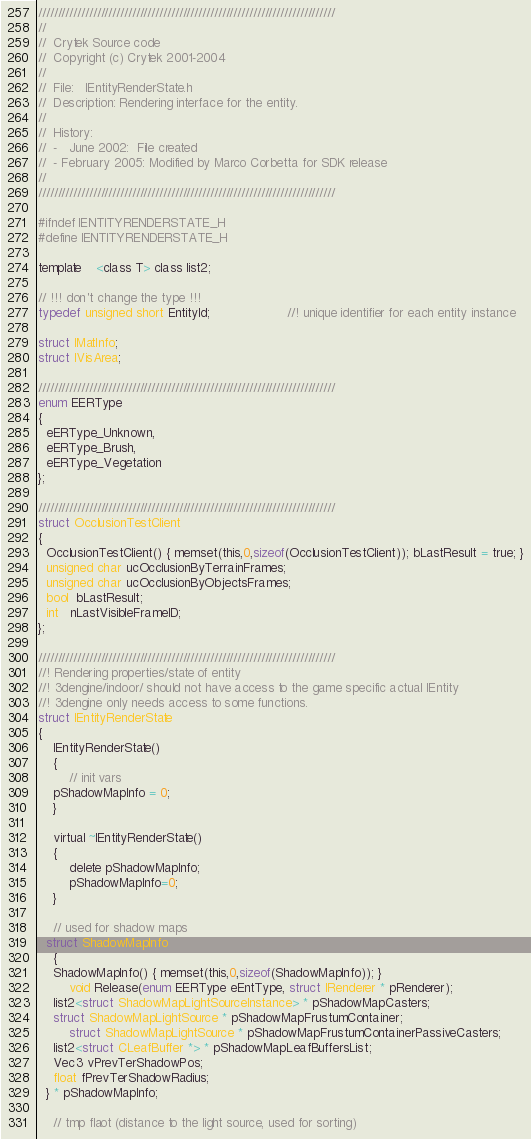Convert code to text. <code><loc_0><loc_0><loc_500><loc_500><_C_>
////////////////////////////////////////////////////////////////////////////
//
//	Crytek Source code 
//	Copyright (c) Crytek 2001-2004
//
//  File:   IEntityRenderState.h
//  Description: Rendering interface for the entity.
//
//  History:
//	-	June 2002:	File created
//	- February 2005: Modified by Marco Corbetta for SDK release
//
////////////////////////////////////////////////////////////////////////////

#ifndef IENTITYRENDERSTATE_H
#define IENTITYRENDERSTATE_H

template	<class T> class list2;

// !!! don't change the type !!!
typedef unsigned short EntityId;					//! unique identifier for each entity instance

struct IMatInfo;
struct IVisArea;

////////////////////////////////////////////////////////////////////////////
enum EERType
{
  eERType_Unknown,
  eERType_Brush,
  eERType_Vegetation
};

////////////////////////////////////////////////////////////////////////////
struct OcclusionTestClient
{
  OcclusionTestClient() { memset(this,0,sizeof(OcclusionTestClient)); bLastResult = true; }
  unsigned char ucOcclusionByTerrainFrames;
  unsigned char ucOcclusionByObjectsFrames;
  bool  bLastResult;
  int   nLastVisibleFrameID;  
};

////////////////////////////////////////////////////////////////////////////
//! Rendering properties/state of entity
//! 3dengine/indoor/ should not have access to the game specific actual IEntity 
//! 3dengine only needs access to some functions.
struct IEntityRenderState
{
	IEntityRenderState()
	{	
		// init vars
    pShadowMapInfo = 0;
	}

	virtual ~IEntityRenderState()
	{
		delete pShadowMapInfo;
		pShadowMapInfo=0;
	}

	// used for shadow maps
  struct ShadowMapInfo
	{
    ShadowMapInfo() { memset(this,0,sizeof(ShadowMapInfo)); }
		void Release(enum EERType eEntType, struct IRenderer * pRenderer);
    list2<struct ShadowMapLightSourceInstance> * pShadowMapCasters;
    struct ShadowMapLightSource * pShadowMapFrustumContainer;
		struct ShadowMapLightSource * pShadowMapFrustumContainerPassiveCasters;
    list2<struct CLeafBuffer *> * pShadowMapLeafBuffersList;
    Vec3 vPrevTerShadowPos; 
    float fPrevTerShadowRadius;
  } * pShadowMapInfo;

	// tmp flaot (distance to the light source, used for sorting)</code> 